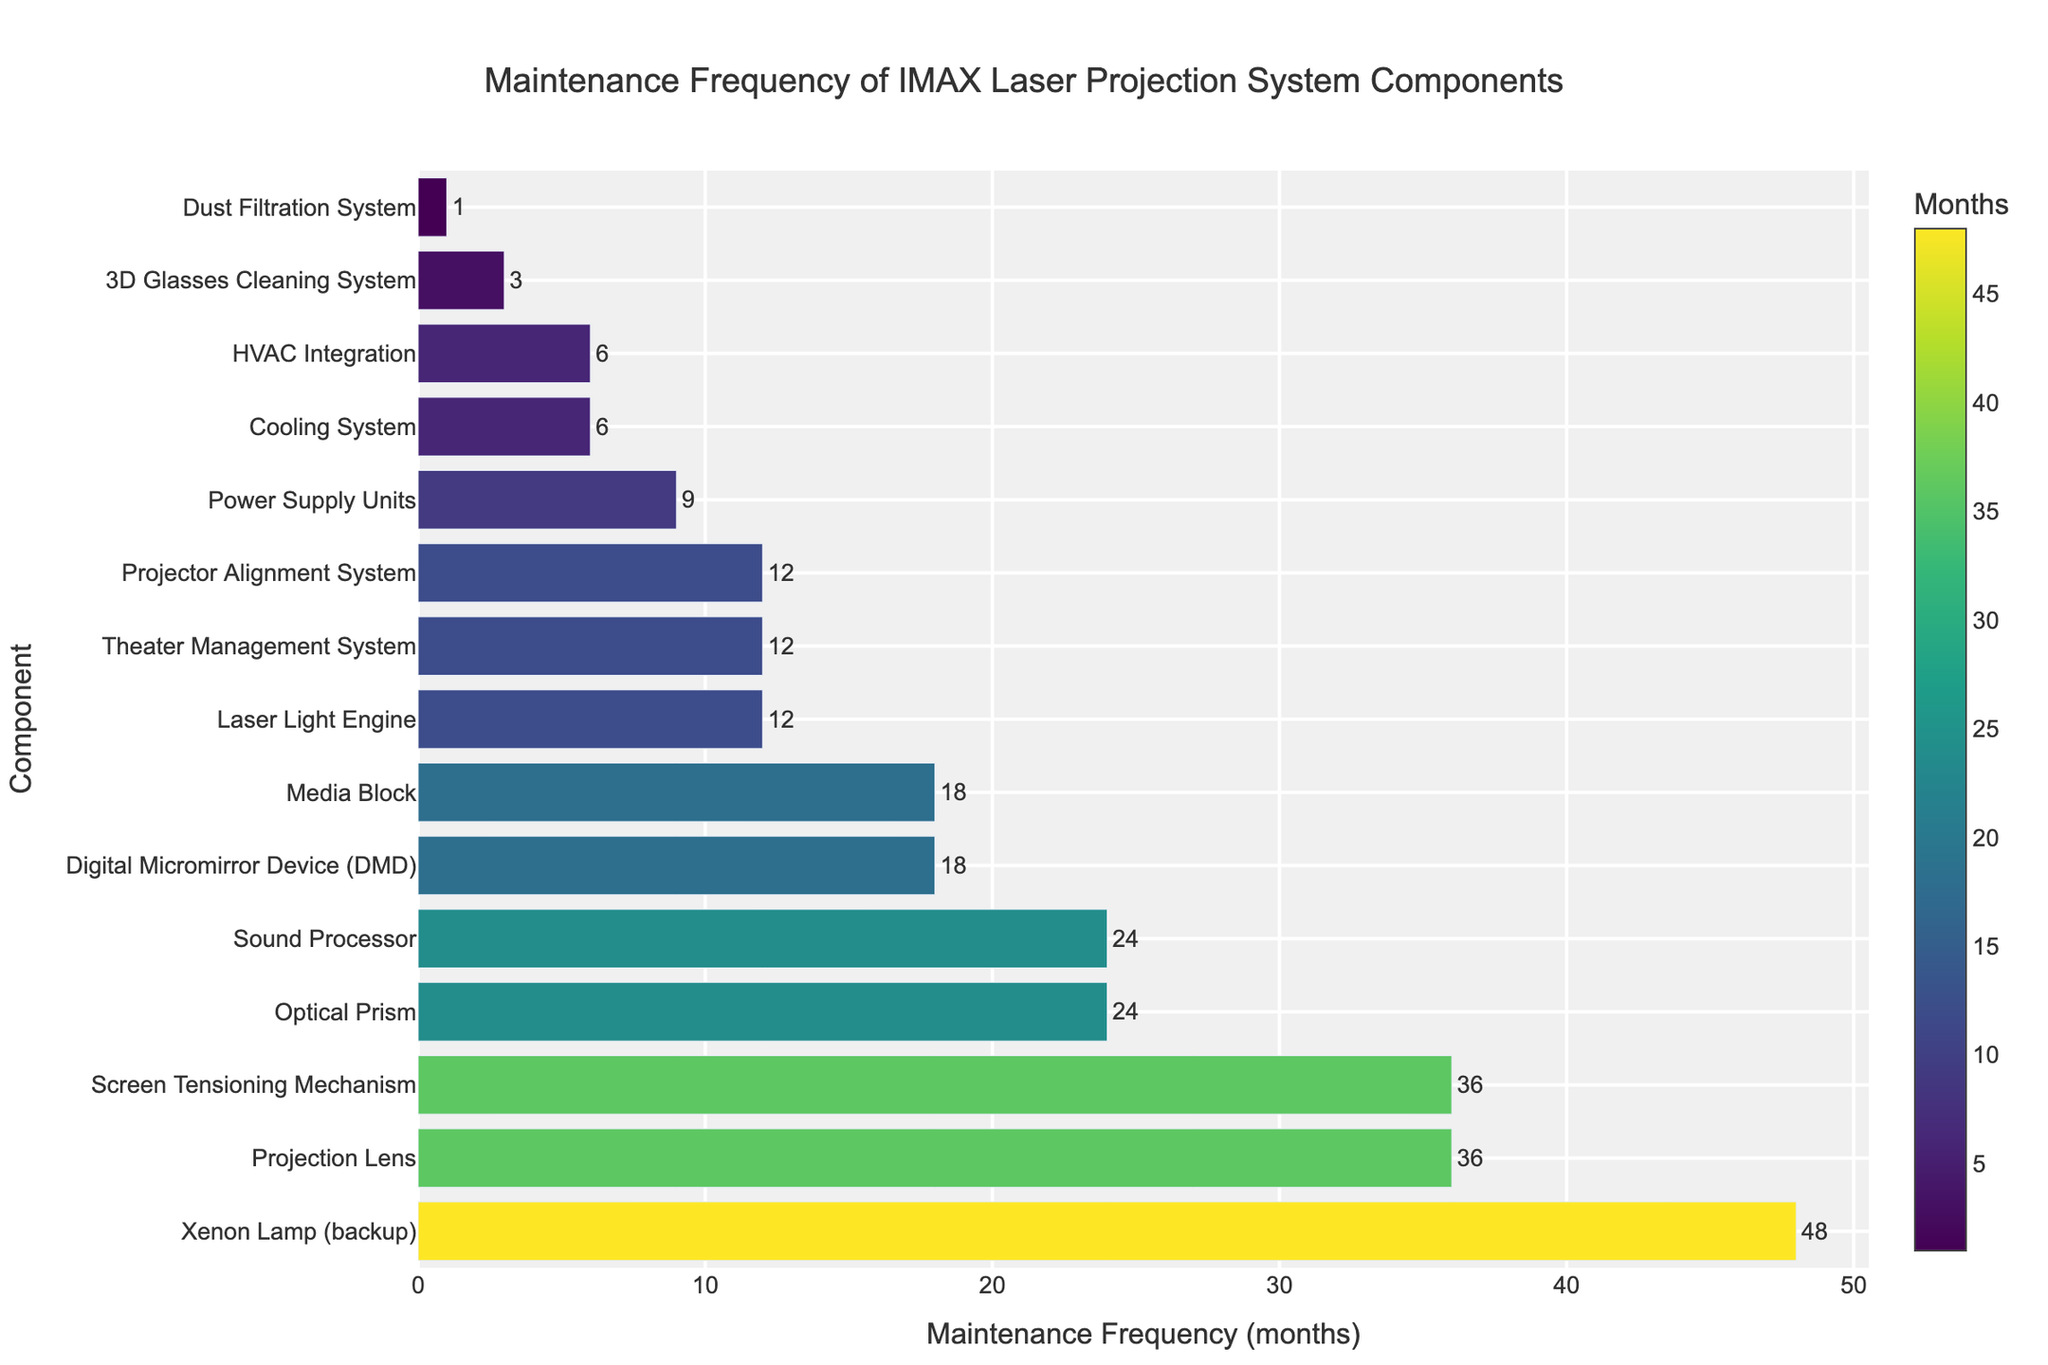Which component has the longest maintenance interval? To find the component with the longest maintenance interval, look for the bar corresponding to the highest frequency in months. The 'Xenon Lamp (backup)' bar is the longest at 48 months.
Answer: Xenon Lamp (backup) Which component requires the most frequent maintenance? Identify the shortest bar on the chart, which indicates the lowest maintenance frequency in months. The 'Dust Filtration System' has the shortest bar at 1 month.
Answer: Dust Filtration System How often does the HVAC Integration need maintenance compared to the Cooling System? Locate the bars for HVAC Integration and Cooling System. The HVAC Integration bar indicates 6 months, identical to the Cooling System, therefore, they both require maintenance every 6 months.
Answer: Same frequency, every 6 months Which component needs maintenance more frequently, the Digital Micromirror Device (DMD) or the Sound Processor? Compare the heights of the bars corresponding to the Digital Micromirror Device (18 months) and the Sound Processor (24 months). The DMD has a lower maintenance frequency at 18 months.
Answer: Digital Micromirror Device (DMD) What is the average maintenance frequency of components with monthly intervals greater than 12 and less than 24 months? Find components with maintenance frequencies between 12 and 24 months ('Digital Micromirror Device', 'Power Supply Units', 'Media Block', 'Sound Processor', 'Optical Prism'). The sum of their maintenance frequencies is (18 + 9 + 18 + 24 + 24) = 93 months. There are 5 components in this range, so the average frequency is 93/5.
Answer: 18.6 months Do more components require maintenance intervals of under a year or over a year? Count the number of components with maintenance frequencies less than 12 months (5 components) and those with 12 months or more (10 components). Components with more than a year of maintenance intervals are more frequent.
Answer: Over a year (10 components) Which components require maintenance every 12 months? Look for bars with a maintenance frequency of exactly 12 months. The components are 'Laser Light Engine', 'Theater Management System', and 'Projector Alignment System'.
Answer: Laser Light Engine, Theater Management System, Projector Alignment System When does the 3D Glasses Cleaning System need maintenance? Check the bar corresponding to the '3D Glasses Cleaning System' for its maintenance frequency, which is 3 months.
Answer: Every 3 months What is the total maintenance interval for 'Power Supply Units' and 'Projection Lens'? Add the maintenance frequencies of 'Power Supply Units' (9 months) and 'Projection Lens' (36 months), resulting in a sum of 45 months.
Answer: 45 months Is the Optical Prism’s maintenance interval longer or shorter than the Media Block’s? Compare the maintenance intervals of 'Optical Prism' (24 months) and 'Media Block' (18 months). The Optical Prism has a longer interval.
Answer: Longer 